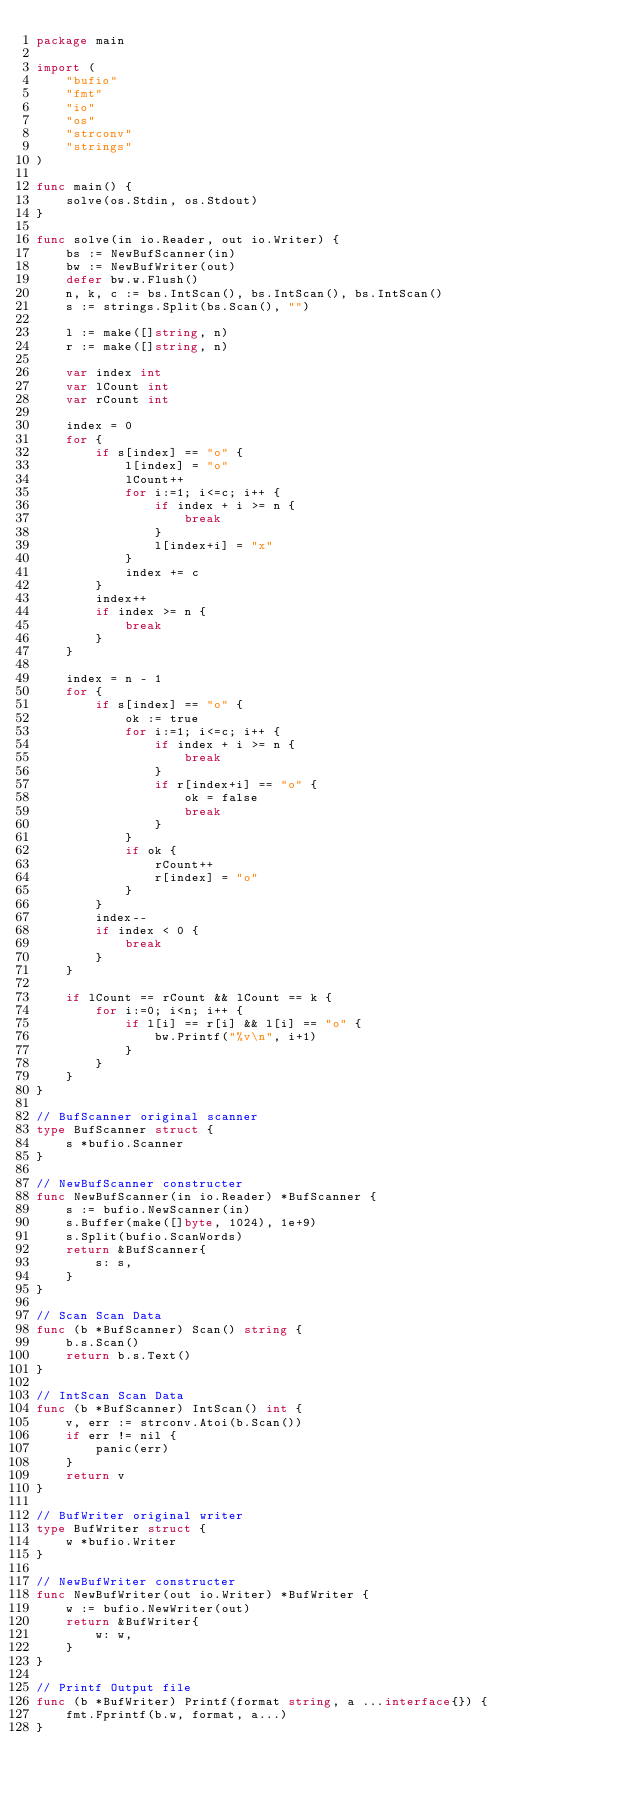Convert code to text. <code><loc_0><loc_0><loc_500><loc_500><_Go_>package main

import (
	"bufio"
	"fmt"
	"io"
	"os"
	"strconv"
	"strings"
)

func main() {
	solve(os.Stdin, os.Stdout)
}

func solve(in io.Reader, out io.Writer) {
	bs := NewBufScanner(in)
	bw := NewBufWriter(out)
	defer bw.w.Flush()
	n, k, c := bs.IntScan(), bs.IntScan(), bs.IntScan()
	s := strings.Split(bs.Scan(), "")

	l := make([]string, n)
	r := make([]string, n)

	var index int
	var lCount int
	var rCount int

	index = 0
	for {
		if s[index] == "o" {
			l[index] = "o"
			lCount++
			for i:=1; i<=c; i++ {
				if index + i >= n {
					break
				}
				l[index+i] = "x"
			}
			index += c
		}
		index++
		if index >= n {
			break
		}
	}

	index = n - 1
	for {
		if s[index] == "o" {
			ok := true
			for i:=1; i<=c; i++ {
				if index + i >= n {
					break
				}
				if r[index+i] == "o" {
					ok = false
					break
				}
			}
			if ok {
				rCount++
				r[index] = "o"
			}
		}
		index--
		if index < 0 {
			break
		}
	}

	if lCount == rCount && lCount == k {
		for i:=0; i<n; i++ {
			if l[i] == r[i] && l[i] == "o" {
				bw.Printf("%v\n", i+1)
			}
		}
	}
}

// BufScanner original scanner
type BufScanner struct {
	s *bufio.Scanner
}

// NewBufScanner constructer
func NewBufScanner(in io.Reader) *BufScanner {
	s := bufio.NewScanner(in)
	s.Buffer(make([]byte, 1024), 1e+9)
	s.Split(bufio.ScanWords)
	return &BufScanner{
		s: s,
	}
}

// Scan Scan Data
func (b *BufScanner) Scan() string {
	b.s.Scan()
	return b.s.Text()
}

// IntScan Scan Data
func (b *BufScanner) IntScan() int {
	v, err := strconv.Atoi(b.Scan())
	if err != nil {
		panic(err)
	}
	return v
}

// BufWriter original writer
type BufWriter struct {
	w *bufio.Writer
}

// NewBufWriter constructer
func NewBufWriter(out io.Writer) *BufWriter {
	w := bufio.NewWriter(out)
	return &BufWriter{
		w: w,
	}
}

// Printf Output file
func (b *BufWriter) Printf(format string, a ...interface{}) {
	fmt.Fprintf(b.w, format, a...)
}</code> 